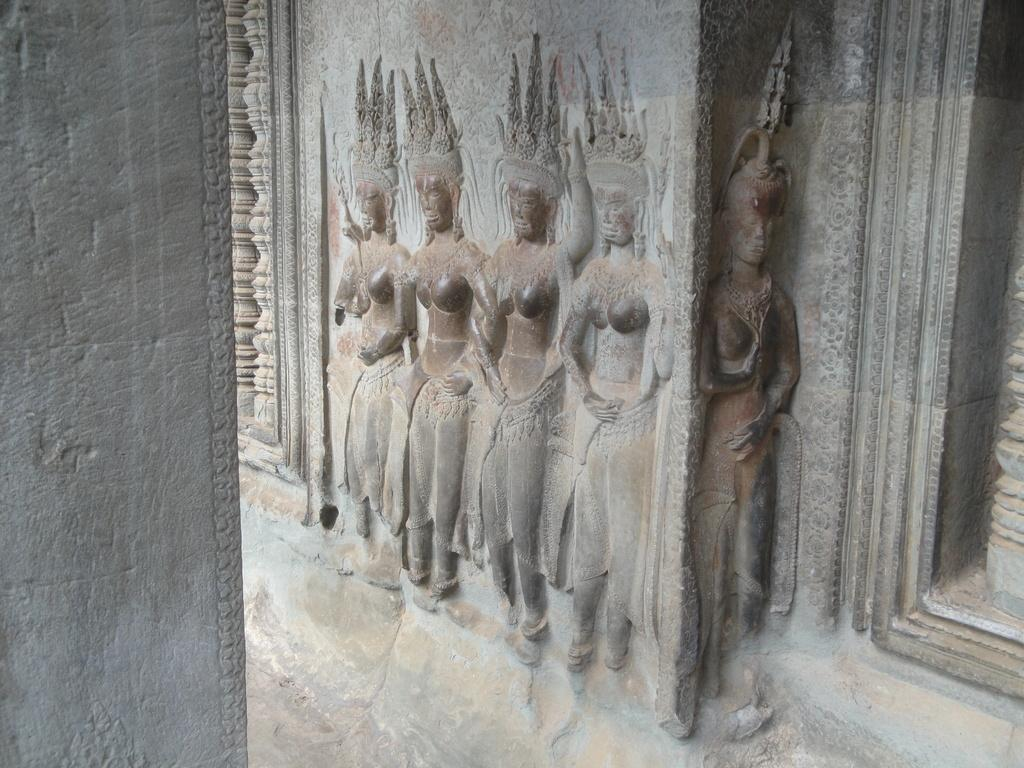What can be seen in the image that resembles human figures? There are statues in the image that resemble human figures. What specific type of statues are depicted in the image? The statues are in the shape of women. Where are the statues located in the image? The statues are on a stone wall. What type of oil is being used to maintain the statues in the image? There is no mention of oil or any maintenance activity in the image; it simply shows statues on a stone wall. 